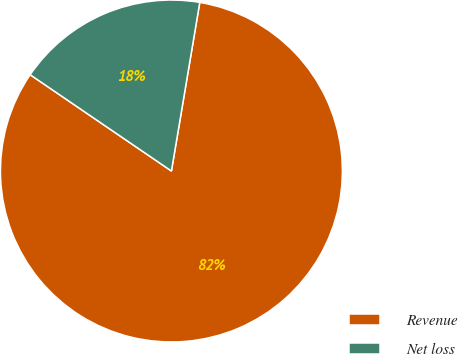<chart> <loc_0><loc_0><loc_500><loc_500><pie_chart><fcel>Revenue<fcel>Net loss<nl><fcel>81.87%<fcel>18.13%<nl></chart> 